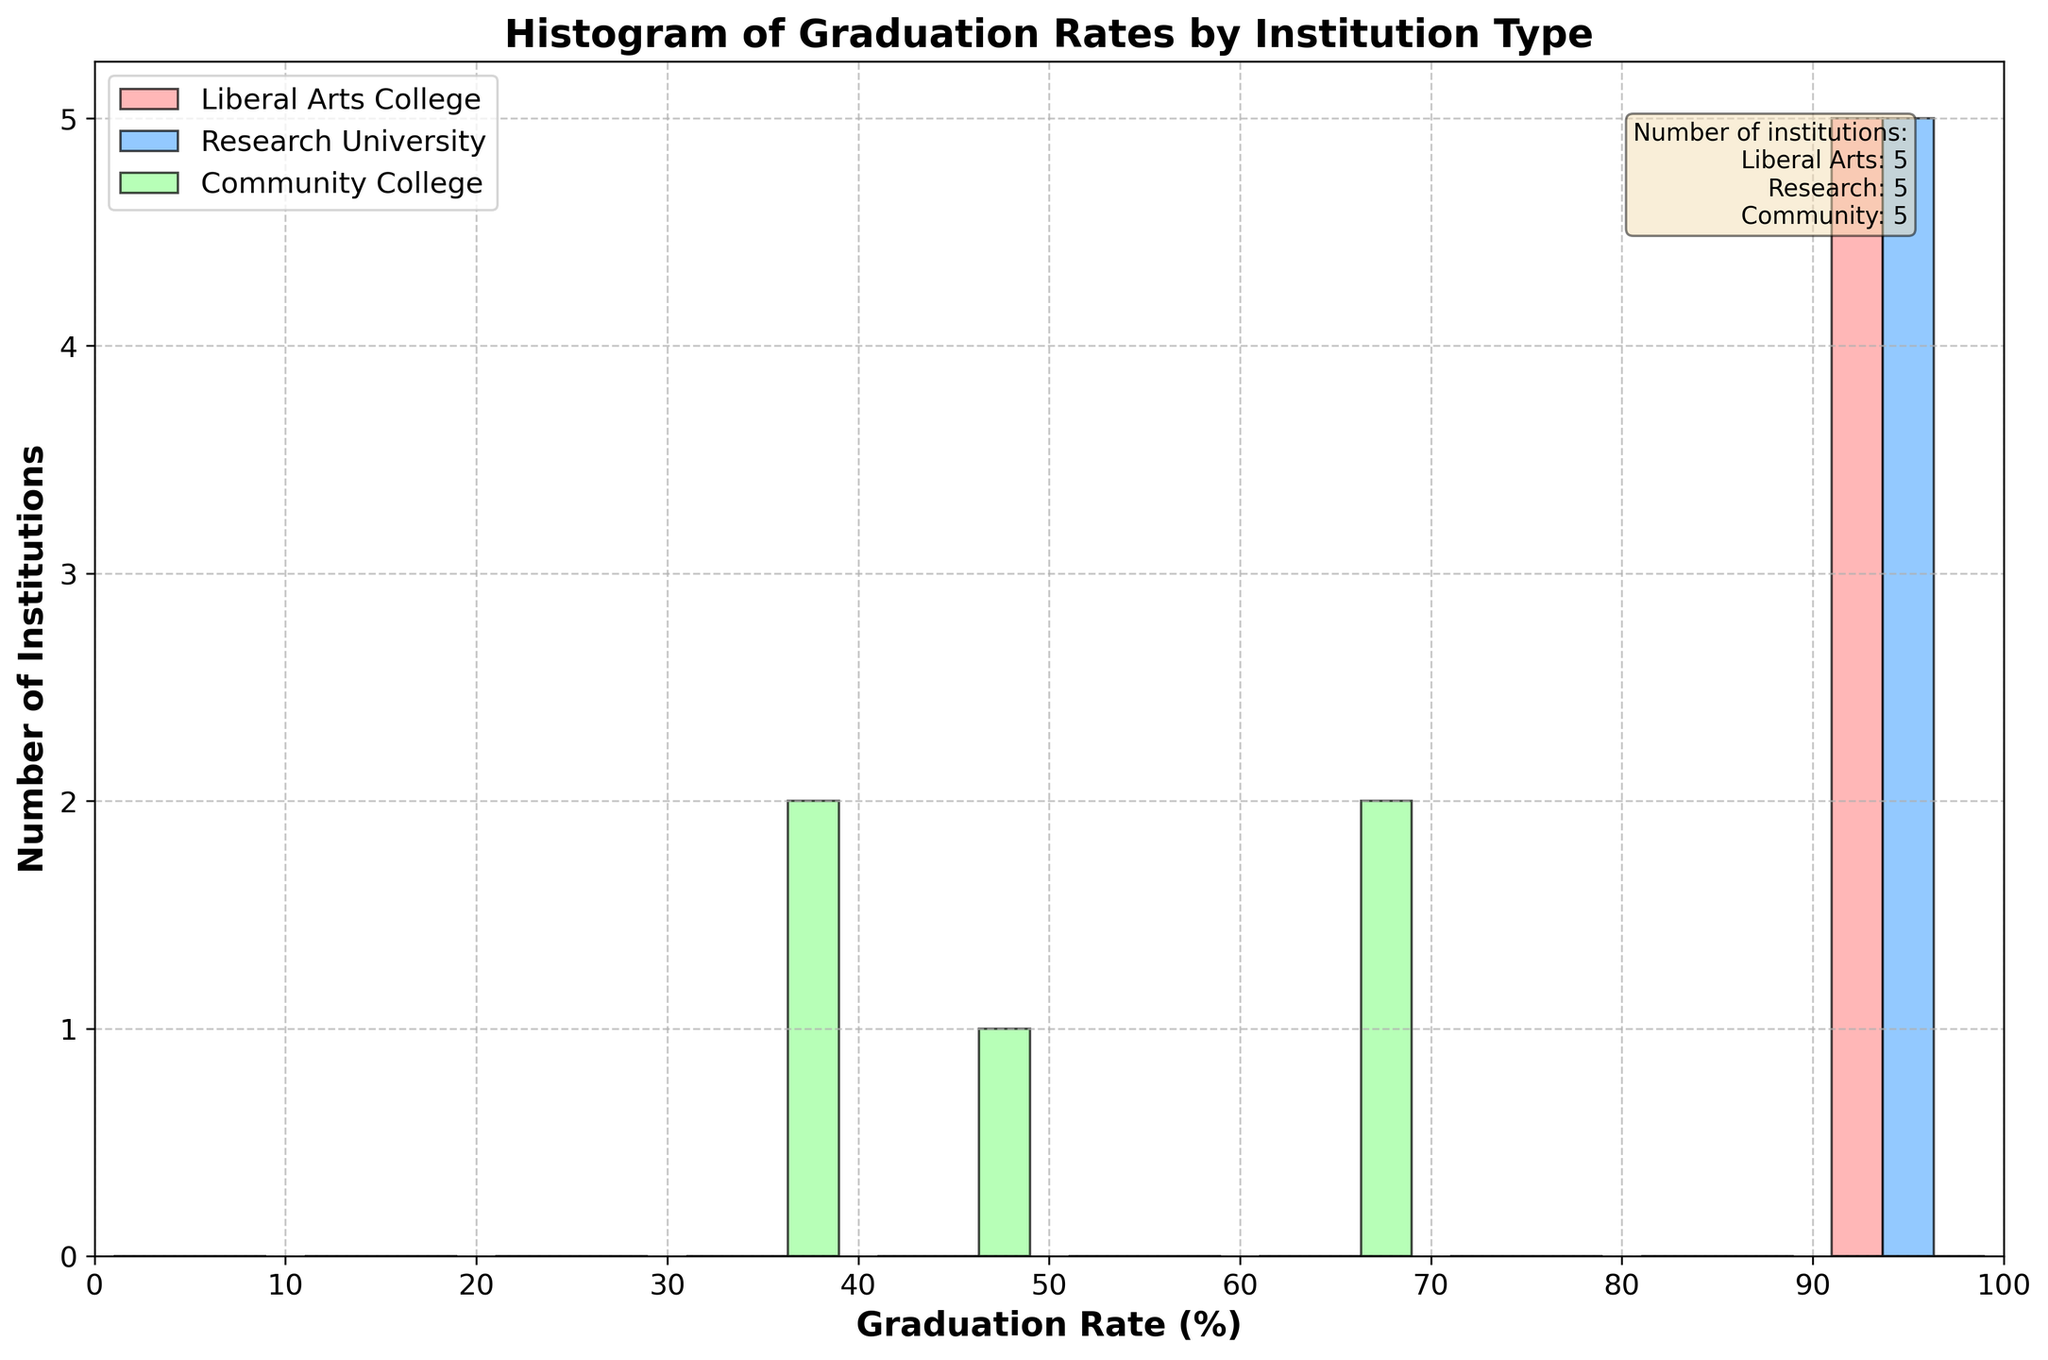How many institution types are represented in the histogram? The histogram legend indicates that there are three types of institutions segmented: Liberal Arts College, Research University, and Community College.
Answer: Three What is the x-axis label in the histogram? The x-axis label in the histogram is "Graduation Rate (%)". This is shown right below the horizontal axis.
Answer: Graduation Rate (%) Which institution type has the highest graduation rate range? By observing the histogram bars, Research Universities have the highest graduation rates, with institutions falling within the 90-100% range.
Answer: Research Universities Which institution type has the lowest graduation rates? The Community Colleges have the lowest graduation rates, as seen by the higher number of institutions in the 30-40% range.
Answer: Community Colleges How many institutions are represented in the Liberal Arts College category? The text box in the top right corner of the histogram provides the number: "Liberal Arts: 5".
Answer: 5 What is the frequency range of the graduation rate for the Community Colleges? Observe the histogram bars for Community Colleges. They are spread from 30% to 70% graduation rate.
Answer: 30% to 70% Compare the number of institutions for Research Universities and Community Colleges with graduation rates above 90%. Only Research Universities have institutions with graduation rates above 90%, while Community Colleges do not.
Answer: Research Universities: 4, Community Colleges: 0 Is there any institution type with no graduation rates below 90%? By examining the histogram, Research Universities and Liberal Arts Colleges do not have any institutions with graduation rates below 90%.
Answer: Yes What is the median graduation rate range for Community Colleges? To find the median, observe the distribution of graduation rates; the median will be around the middle of the spread. For Community Colleges, graduation rates mostly lie within the 30-70% range. Therefore, the median falls around the 50-60% range.
Answer: 50-60% How does the distribution of graduation rates compare between Liberal Arts Colleges and Community Colleges? Liberal Arts Colleges generally have higher graduation rates clustered around the 90-100% range, while Community Colleges show spread across the 30-70% range. This signifies that Liberal Arts Colleges tend to have much higher graduation rates compared to Community Colleges.
Answer: Liberal Arts Colleges have higher graduation rates overall compared to Community Colleges 